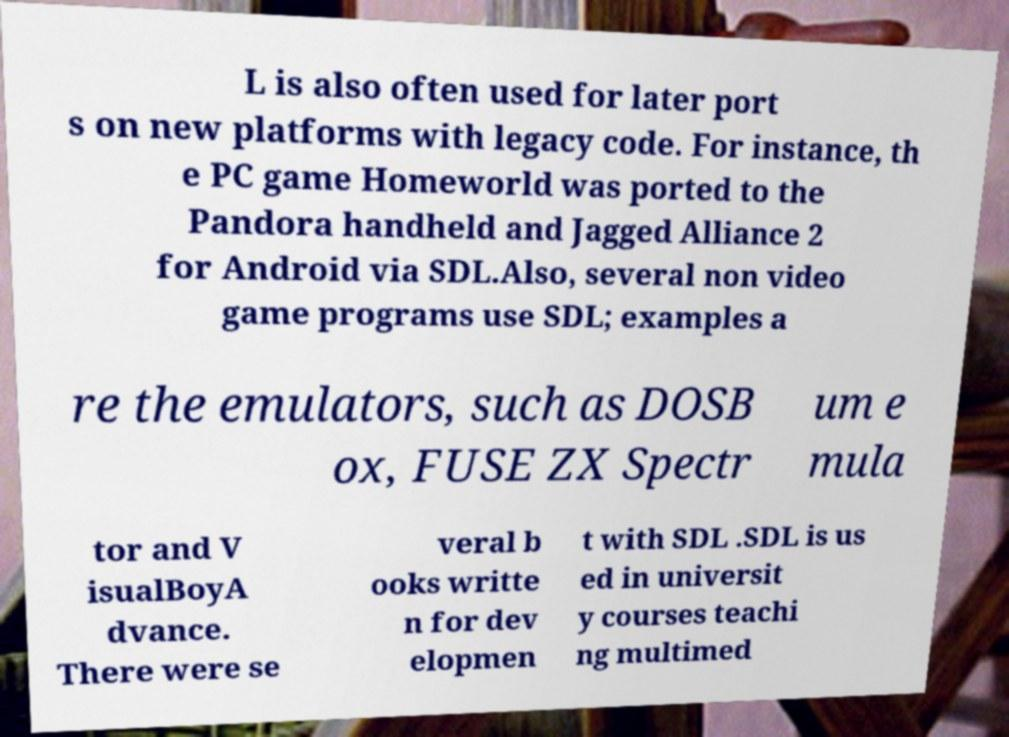What messages or text are displayed in this image? I need them in a readable, typed format. L is also often used for later port s on new platforms with legacy code. For instance, th e PC game Homeworld was ported to the Pandora handheld and Jagged Alliance 2 for Android via SDL.Also, several non video game programs use SDL; examples a re the emulators, such as DOSB ox, FUSE ZX Spectr um e mula tor and V isualBoyA dvance. There were se veral b ooks writte n for dev elopmen t with SDL .SDL is us ed in universit y courses teachi ng multimed 